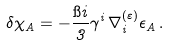<formula> <loc_0><loc_0><loc_500><loc_500>\delta \chi _ { A } = - \frac { \i i } { 3 } \gamma ^ { i } \, \nabla _ { i } ^ { ( \varepsilon ) } \epsilon _ { A } \, .</formula> 